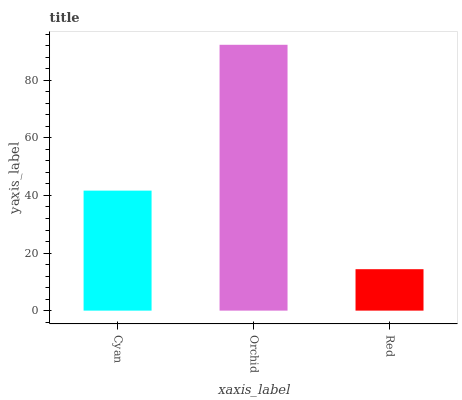Is Red the minimum?
Answer yes or no. Yes. Is Orchid the maximum?
Answer yes or no. Yes. Is Orchid the minimum?
Answer yes or no. No. Is Red the maximum?
Answer yes or no. No. Is Orchid greater than Red?
Answer yes or no. Yes. Is Red less than Orchid?
Answer yes or no. Yes. Is Red greater than Orchid?
Answer yes or no. No. Is Orchid less than Red?
Answer yes or no. No. Is Cyan the high median?
Answer yes or no. Yes. Is Cyan the low median?
Answer yes or no. Yes. Is Red the high median?
Answer yes or no. No. Is Red the low median?
Answer yes or no. No. 